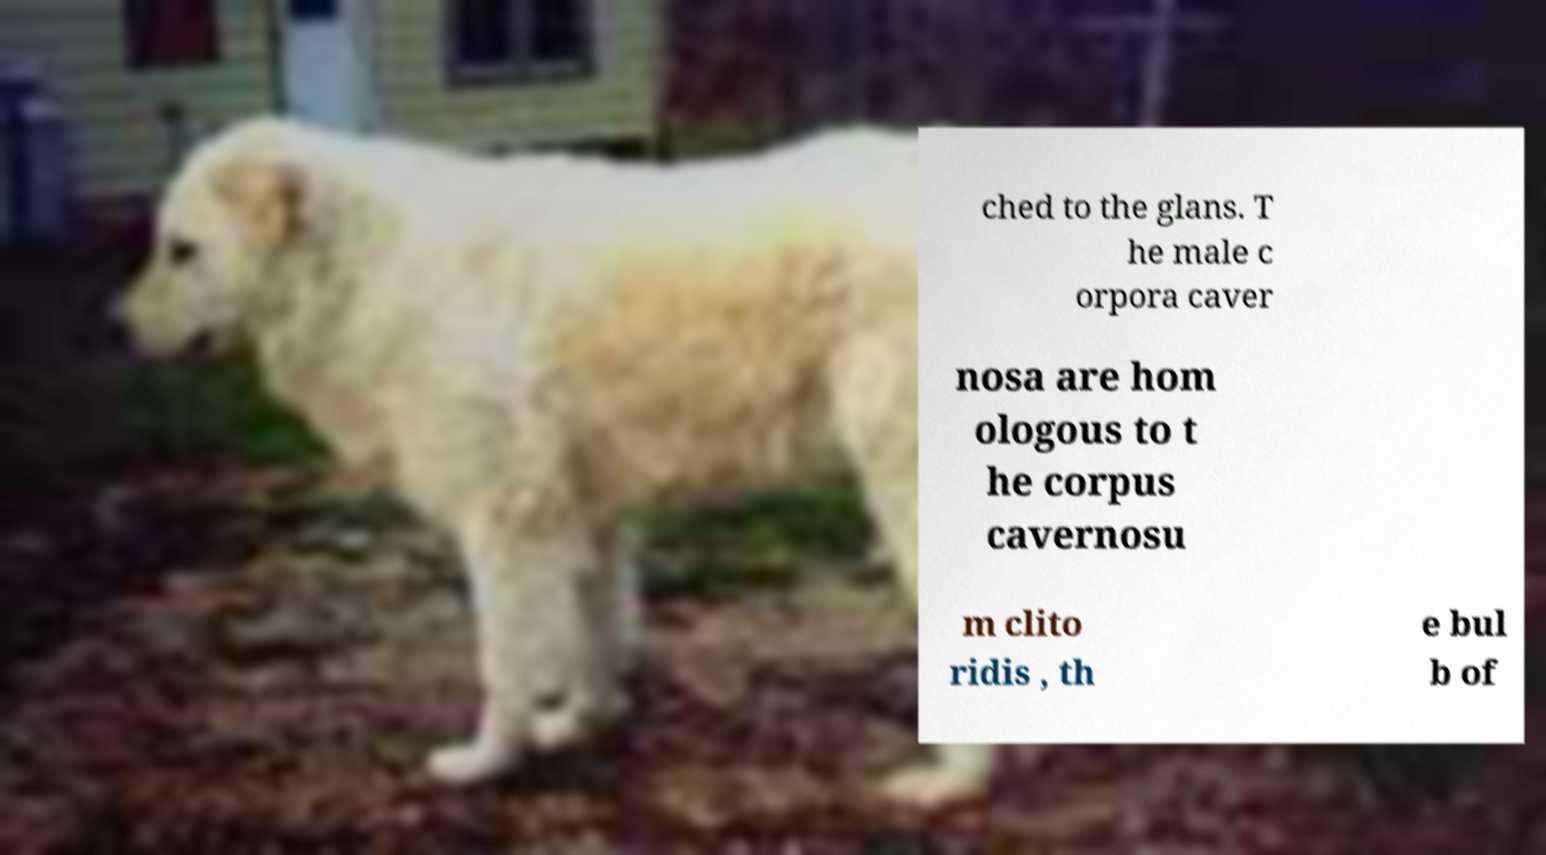Please identify and transcribe the text found in this image. ched to the glans. T he male c orpora caver nosa are hom ologous to t he corpus cavernosu m clito ridis , th e bul b of 